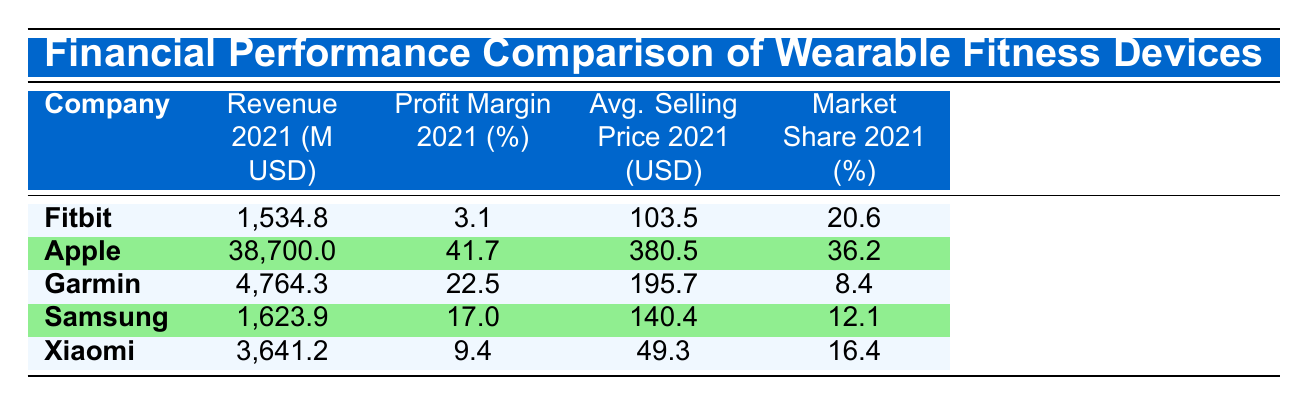What was the profit margin for Fitbit in 2021? From the table, Fitbit's profit margin in 2021 is specifically listed under the Profit Margin 2021 column, which shows a value of 3.1 percent.
Answer: 3.1 percent Which company had the highest revenue in 2021? The revenue for each company in 2021 is visible in the Revenue 2021 column. Apple has the highest revenue at 38,700 million USD, compared to other companies.
Answer: Apple What is the difference in average selling price between Apple and Xiaomi in 2021? The average selling price for Apple in 2021 is 380.5 USD and for Xiaomi, it is 49.3 USD. The difference is calculated as 380.5 - 49.3 = 331.2 USD.
Answer: 331.2 USD Did Garmin's market share increase from 2019 to 2021? Garmin's market shares are listed for each year. In 2019, it was 7.9 percent and in 2021, it rose to 8.4 percent, indicating an increase.
Answer: Yes What is the total revenue of Fitbit and Samsung in 2021? The revenue for Fitbit is 1,534.8 million USD and for Samsung, it is 1,623.9 million USD. Adding these two gives 1,534.8 + 1,623.9 = 3,158.7 million USD.
Answer: 3,158.7 million USD Which company had the lowest profit margin in 2021? By reviewing the Profit Margin 2021 column, Xiaomi has the lowest profit margin at 9.4 percent.
Answer: Xiaomi What was the average market share of the listed companies in 2021? The market shares for 2021 are: Apple (36.2%), Fitbit (20.6%), Garmin (8.4%), Samsung (12.1%), and Xiaomi (16.4%). Summing them gives 93.7%. Dividing by the number of companies (5) results in an average of 18.74%.
Answer: 18.74% Is Fitbit's average selling price higher than Samsung's in 2021? The average selling price for Fitbit is 103.5 USD compared to Samsung's 140.4 USD in 2021, meaning Fitbit's price is lower.
Answer: No 